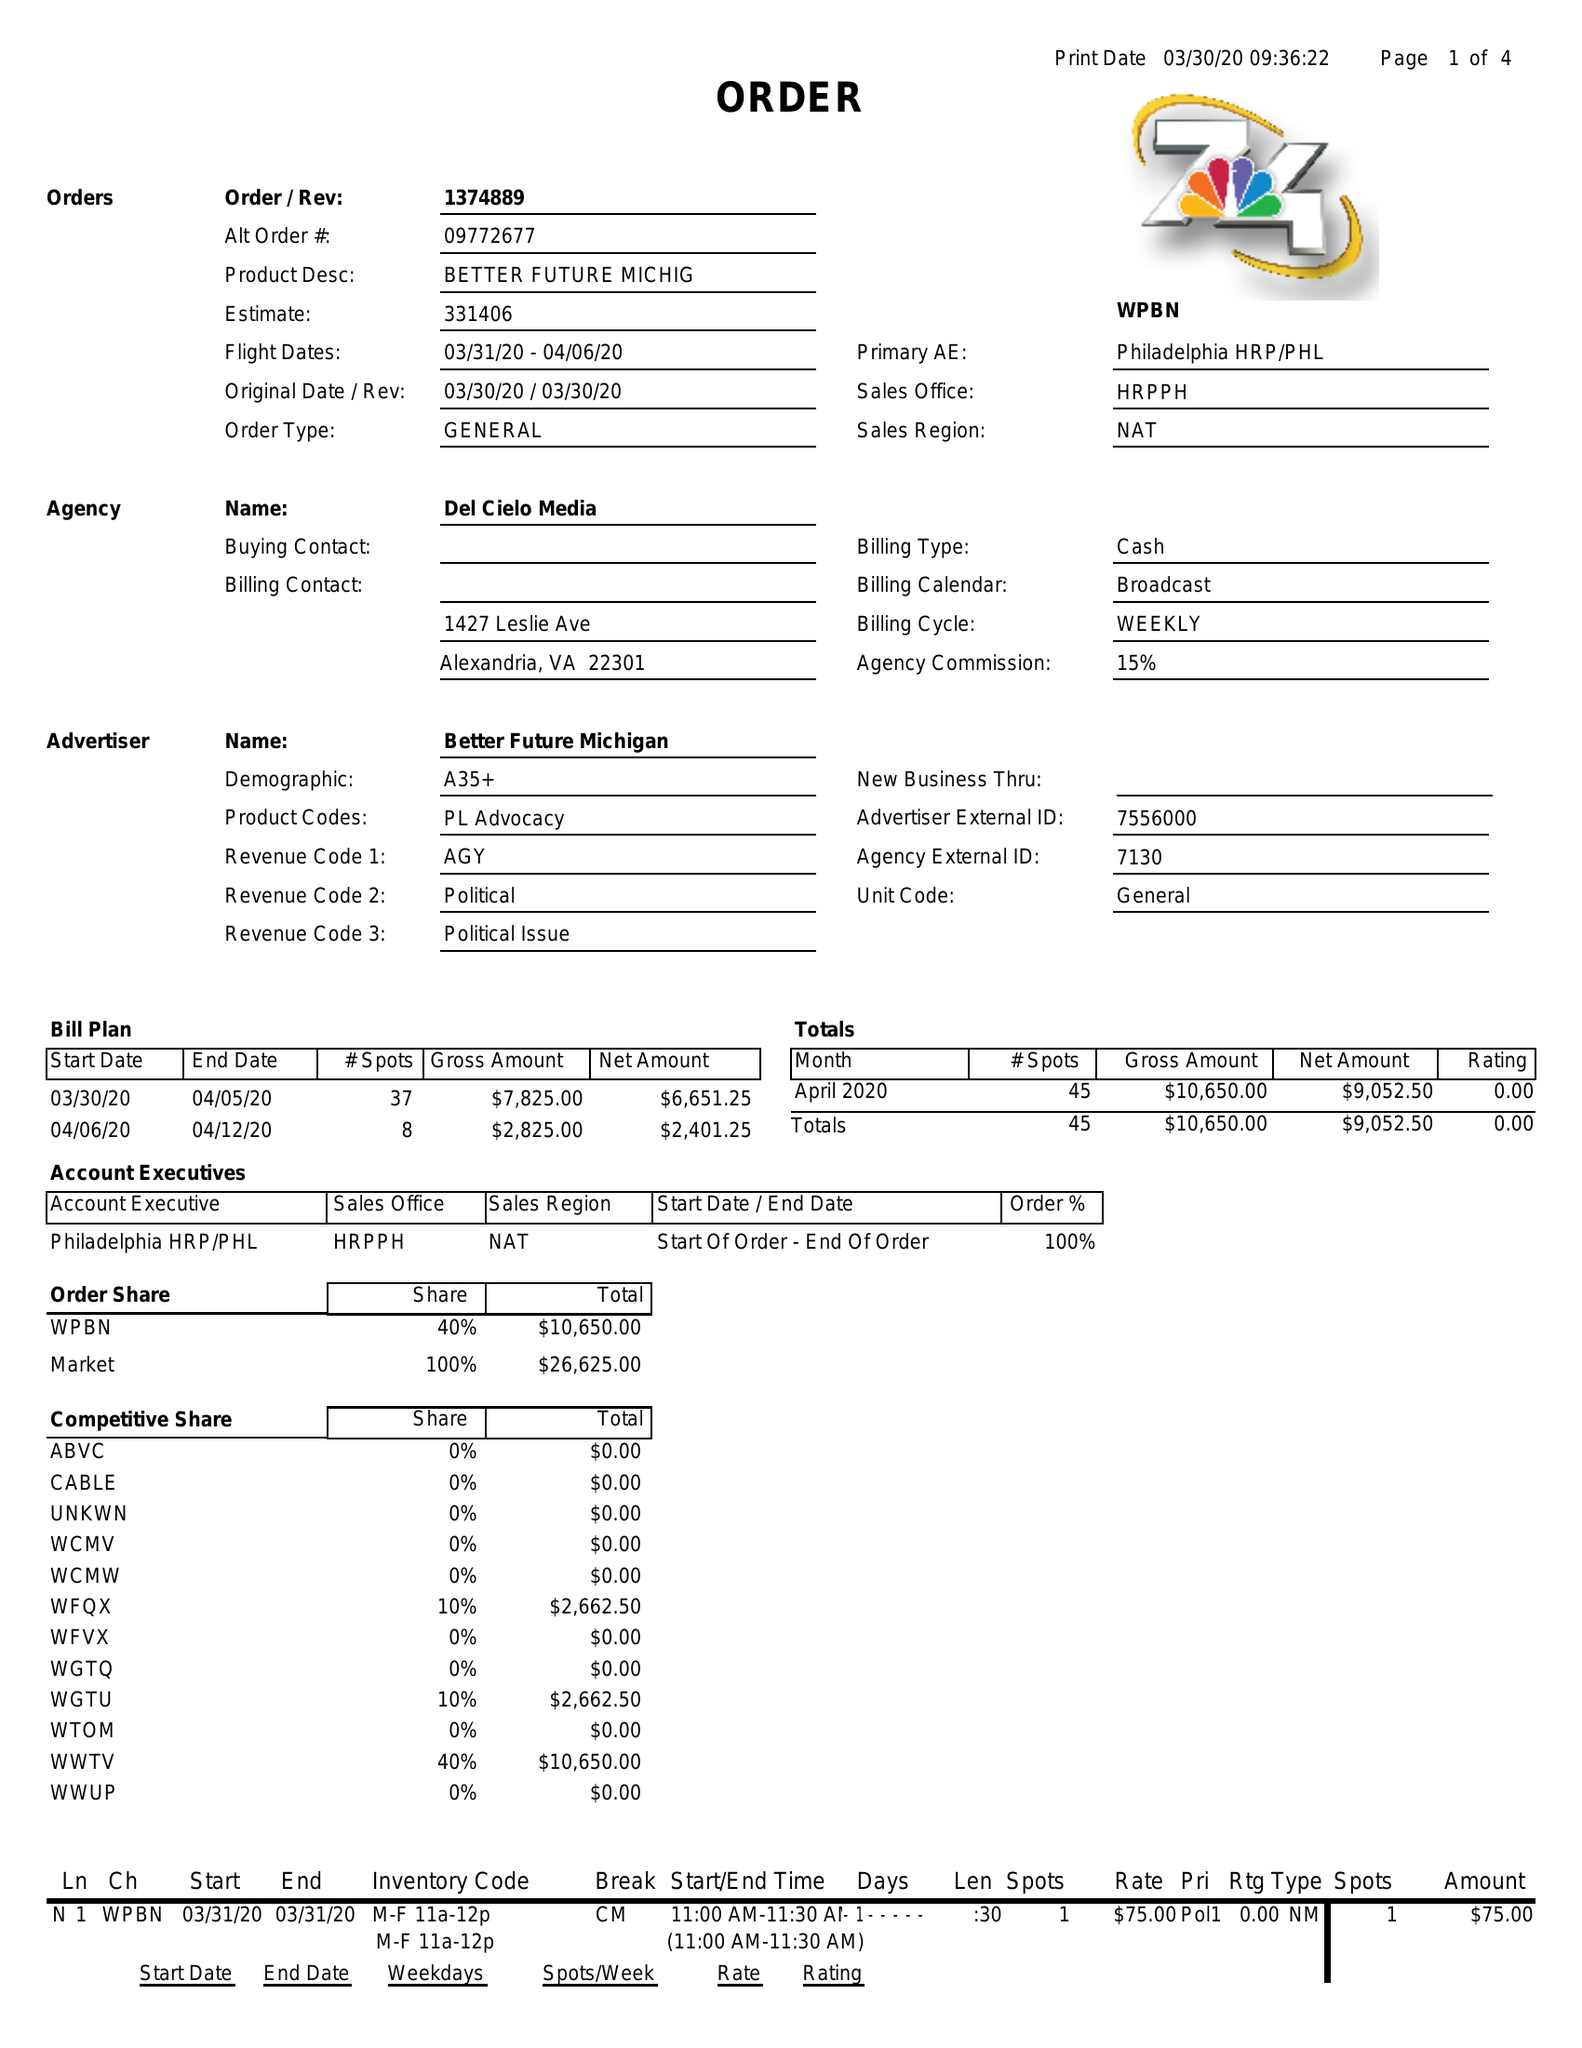What is the value for the gross_amount?
Answer the question using a single word or phrase. 10650.00 